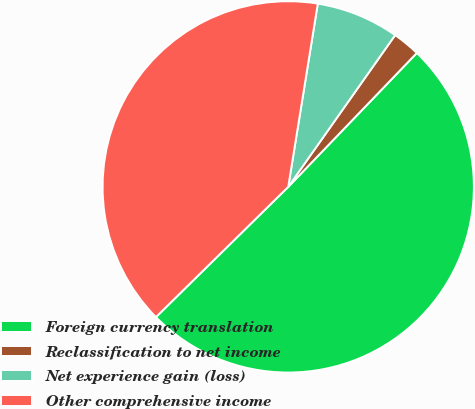Convert chart. <chart><loc_0><loc_0><loc_500><loc_500><pie_chart><fcel>Foreign currency translation<fcel>Reclassification to net income<fcel>Net experience gain (loss)<fcel>Other comprehensive income<nl><fcel>50.45%<fcel>2.41%<fcel>7.22%<fcel>39.92%<nl></chart> 